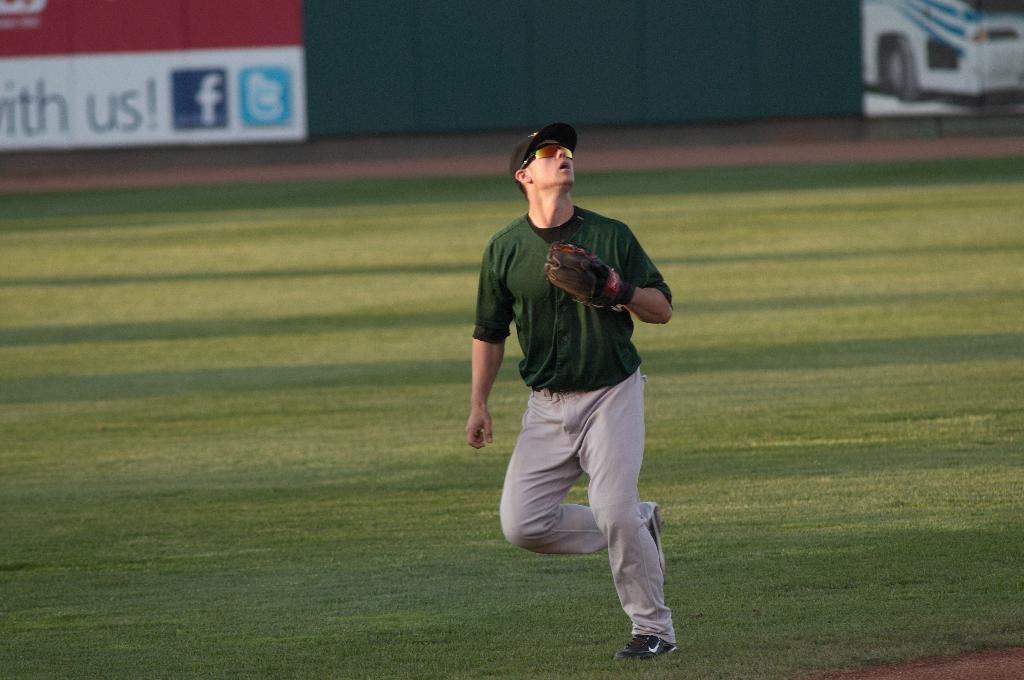<image>
Describe the image concisely. A facebook logo can be seen next to the word us on a sign in a baseball diamond. 